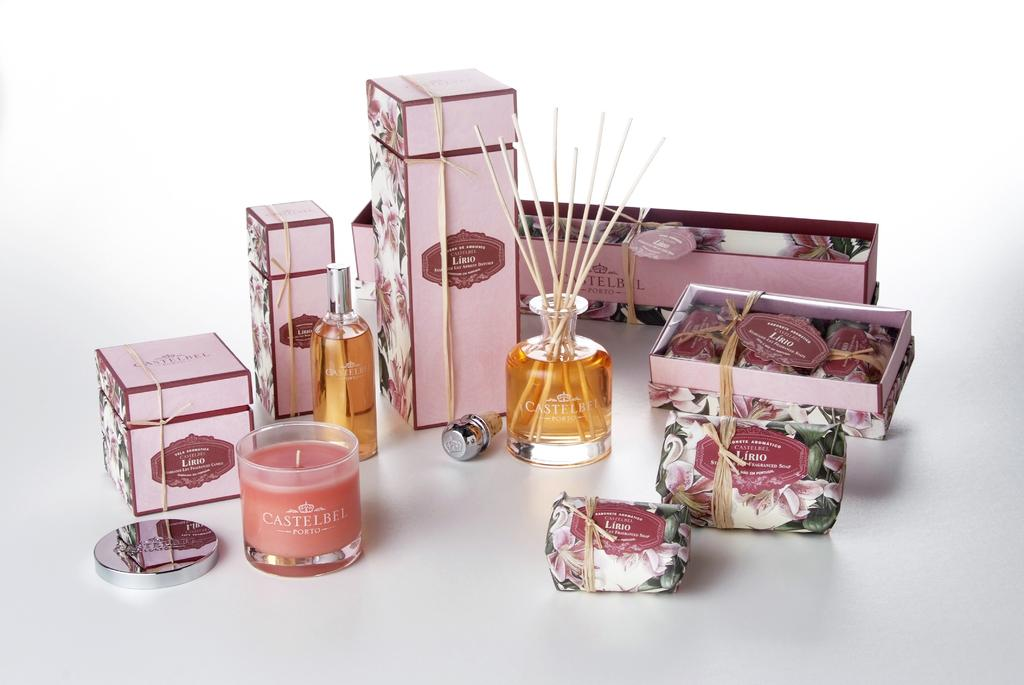<image>
Describe the image concisely. Various Castelbel products from soaps to candles all in the Lirio scent. 